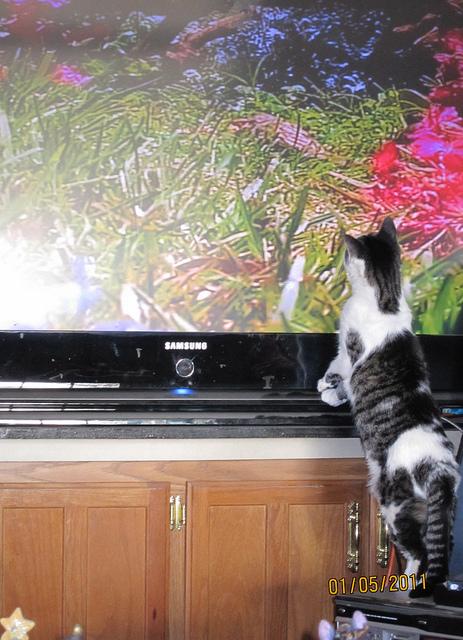What color is the cat?
Keep it brief. Black and white. What is the cat doing?
Short answer required. Watching tv. What is the brand of this television?
Answer briefly. Samsung. 